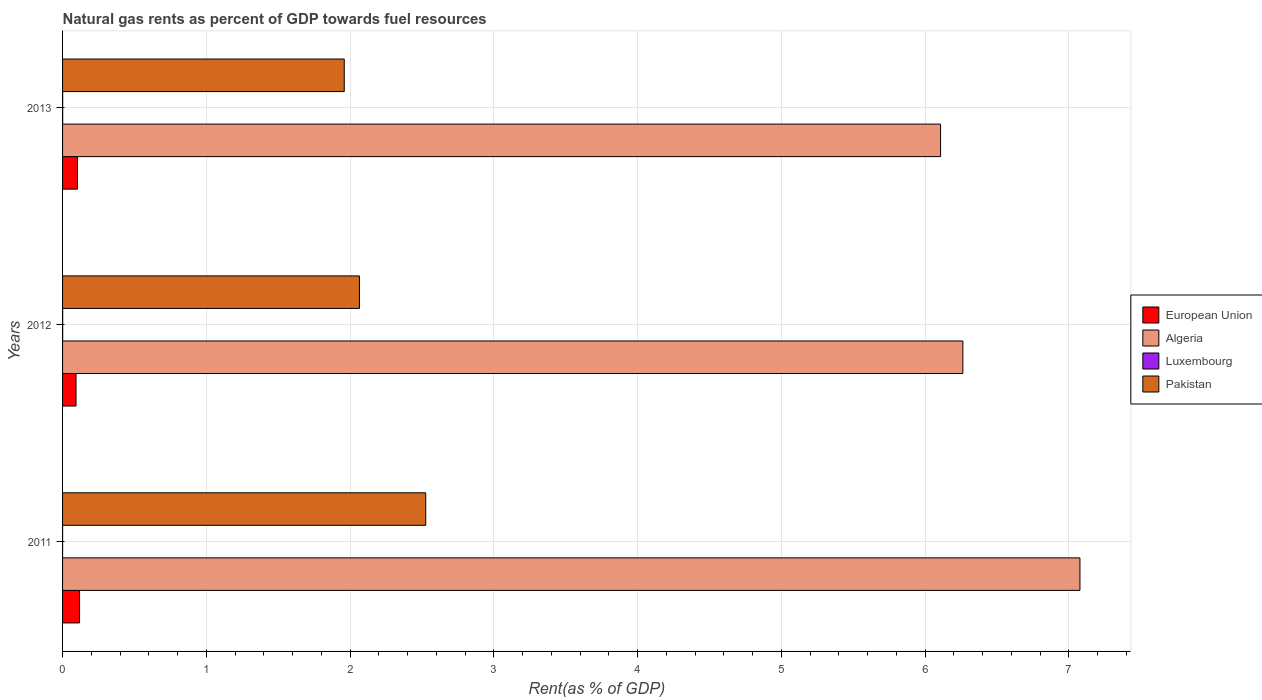How many different coloured bars are there?
Provide a short and direct response. 4. In how many cases, is the number of bars for a given year not equal to the number of legend labels?
Your response must be concise. 0. What is the matural gas rent in Algeria in 2011?
Ensure brevity in your answer.  7.08. Across all years, what is the maximum matural gas rent in Algeria?
Your answer should be very brief. 7.08. Across all years, what is the minimum matural gas rent in European Union?
Offer a terse response. 0.09. In which year was the matural gas rent in Algeria maximum?
Your answer should be compact. 2011. In which year was the matural gas rent in Luxembourg minimum?
Provide a short and direct response. 2011. What is the total matural gas rent in Luxembourg in the graph?
Provide a short and direct response. 0. What is the difference between the matural gas rent in European Union in 2011 and that in 2012?
Offer a terse response. 0.02. What is the difference between the matural gas rent in European Union in 2011 and the matural gas rent in Pakistan in 2012?
Provide a short and direct response. -1.95. What is the average matural gas rent in European Union per year?
Keep it short and to the point. 0.11. In the year 2013, what is the difference between the matural gas rent in European Union and matural gas rent in Pakistan?
Offer a terse response. -1.86. In how many years, is the matural gas rent in Pakistan greater than 6.2 %?
Make the answer very short. 0. What is the ratio of the matural gas rent in Algeria in 2011 to that in 2013?
Offer a terse response. 1.16. Is the matural gas rent in Luxembourg in 2011 less than that in 2012?
Your response must be concise. Yes. Is the difference between the matural gas rent in European Union in 2012 and 2013 greater than the difference between the matural gas rent in Pakistan in 2012 and 2013?
Your response must be concise. No. What is the difference between the highest and the second highest matural gas rent in Pakistan?
Give a very brief answer. 0.46. What is the difference between the highest and the lowest matural gas rent in Luxembourg?
Your answer should be very brief. 0. In how many years, is the matural gas rent in Luxembourg greater than the average matural gas rent in Luxembourg taken over all years?
Offer a very short reply. 2. Is the sum of the matural gas rent in Pakistan in 2012 and 2013 greater than the maximum matural gas rent in Algeria across all years?
Provide a short and direct response. No. Is it the case that in every year, the sum of the matural gas rent in Algeria and matural gas rent in European Union is greater than the sum of matural gas rent in Luxembourg and matural gas rent in Pakistan?
Your answer should be compact. Yes. What does the 2nd bar from the top in 2013 represents?
Your response must be concise. Luxembourg. How many bars are there?
Your answer should be very brief. 12. Does the graph contain any zero values?
Your response must be concise. No. Where does the legend appear in the graph?
Offer a terse response. Center right. How many legend labels are there?
Your answer should be compact. 4. How are the legend labels stacked?
Your answer should be very brief. Vertical. What is the title of the graph?
Provide a short and direct response. Natural gas rents as percent of GDP towards fuel resources. What is the label or title of the X-axis?
Give a very brief answer. Rent(as % of GDP). What is the label or title of the Y-axis?
Your answer should be compact. Years. What is the Rent(as % of GDP) of European Union in 2011?
Keep it short and to the point. 0.12. What is the Rent(as % of GDP) in Algeria in 2011?
Provide a succinct answer. 7.08. What is the Rent(as % of GDP) of Luxembourg in 2011?
Give a very brief answer. 0. What is the Rent(as % of GDP) of Pakistan in 2011?
Keep it short and to the point. 2.53. What is the Rent(as % of GDP) of European Union in 2012?
Your answer should be compact. 0.09. What is the Rent(as % of GDP) in Algeria in 2012?
Give a very brief answer. 6.26. What is the Rent(as % of GDP) of Luxembourg in 2012?
Keep it short and to the point. 0. What is the Rent(as % of GDP) in Pakistan in 2012?
Provide a succinct answer. 2.07. What is the Rent(as % of GDP) of European Union in 2013?
Your response must be concise. 0.1. What is the Rent(as % of GDP) of Algeria in 2013?
Offer a terse response. 6.11. What is the Rent(as % of GDP) of Luxembourg in 2013?
Give a very brief answer. 0. What is the Rent(as % of GDP) in Pakistan in 2013?
Ensure brevity in your answer.  1.96. Across all years, what is the maximum Rent(as % of GDP) of European Union?
Give a very brief answer. 0.12. Across all years, what is the maximum Rent(as % of GDP) of Algeria?
Make the answer very short. 7.08. Across all years, what is the maximum Rent(as % of GDP) in Luxembourg?
Provide a succinct answer. 0. Across all years, what is the maximum Rent(as % of GDP) in Pakistan?
Make the answer very short. 2.53. Across all years, what is the minimum Rent(as % of GDP) of European Union?
Offer a terse response. 0.09. Across all years, what is the minimum Rent(as % of GDP) of Algeria?
Keep it short and to the point. 6.11. Across all years, what is the minimum Rent(as % of GDP) in Luxembourg?
Your answer should be compact. 0. Across all years, what is the minimum Rent(as % of GDP) of Pakistan?
Your answer should be very brief. 1.96. What is the total Rent(as % of GDP) in European Union in the graph?
Your response must be concise. 0.32. What is the total Rent(as % of GDP) of Algeria in the graph?
Provide a succinct answer. 19.45. What is the total Rent(as % of GDP) in Luxembourg in the graph?
Your answer should be very brief. 0. What is the total Rent(as % of GDP) in Pakistan in the graph?
Make the answer very short. 6.55. What is the difference between the Rent(as % of GDP) in European Union in 2011 and that in 2012?
Keep it short and to the point. 0.02. What is the difference between the Rent(as % of GDP) of Algeria in 2011 and that in 2012?
Offer a very short reply. 0.81. What is the difference between the Rent(as % of GDP) of Luxembourg in 2011 and that in 2012?
Offer a very short reply. -0. What is the difference between the Rent(as % of GDP) in Pakistan in 2011 and that in 2012?
Provide a short and direct response. 0.46. What is the difference between the Rent(as % of GDP) in European Union in 2011 and that in 2013?
Make the answer very short. 0.01. What is the difference between the Rent(as % of GDP) in Algeria in 2011 and that in 2013?
Keep it short and to the point. 0.97. What is the difference between the Rent(as % of GDP) of Luxembourg in 2011 and that in 2013?
Your answer should be very brief. -0. What is the difference between the Rent(as % of GDP) of Pakistan in 2011 and that in 2013?
Your answer should be very brief. 0.57. What is the difference between the Rent(as % of GDP) in European Union in 2012 and that in 2013?
Your answer should be very brief. -0.01. What is the difference between the Rent(as % of GDP) in Algeria in 2012 and that in 2013?
Offer a terse response. 0.15. What is the difference between the Rent(as % of GDP) in Pakistan in 2012 and that in 2013?
Offer a very short reply. 0.11. What is the difference between the Rent(as % of GDP) in European Union in 2011 and the Rent(as % of GDP) in Algeria in 2012?
Make the answer very short. -6.14. What is the difference between the Rent(as % of GDP) of European Union in 2011 and the Rent(as % of GDP) of Luxembourg in 2012?
Provide a succinct answer. 0.12. What is the difference between the Rent(as % of GDP) in European Union in 2011 and the Rent(as % of GDP) in Pakistan in 2012?
Provide a succinct answer. -1.95. What is the difference between the Rent(as % of GDP) in Algeria in 2011 and the Rent(as % of GDP) in Luxembourg in 2012?
Ensure brevity in your answer.  7.08. What is the difference between the Rent(as % of GDP) in Algeria in 2011 and the Rent(as % of GDP) in Pakistan in 2012?
Provide a short and direct response. 5.01. What is the difference between the Rent(as % of GDP) of Luxembourg in 2011 and the Rent(as % of GDP) of Pakistan in 2012?
Your answer should be compact. -2.06. What is the difference between the Rent(as % of GDP) in European Union in 2011 and the Rent(as % of GDP) in Algeria in 2013?
Give a very brief answer. -5.99. What is the difference between the Rent(as % of GDP) in European Union in 2011 and the Rent(as % of GDP) in Luxembourg in 2013?
Your answer should be very brief. 0.12. What is the difference between the Rent(as % of GDP) in European Union in 2011 and the Rent(as % of GDP) in Pakistan in 2013?
Offer a terse response. -1.84. What is the difference between the Rent(as % of GDP) of Algeria in 2011 and the Rent(as % of GDP) of Luxembourg in 2013?
Make the answer very short. 7.08. What is the difference between the Rent(as % of GDP) in Algeria in 2011 and the Rent(as % of GDP) in Pakistan in 2013?
Provide a short and direct response. 5.12. What is the difference between the Rent(as % of GDP) of Luxembourg in 2011 and the Rent(as % of GDP) of Pakistan in 2013?
Keep it short and to the point. -1.96. What is the difference between the Rent(as % of GDP) in European Union in 2012 and the Rent(as % of GDP) in Algeria in 2013?
Give a very brief answer. -6.01. What is the difference between the Rent(as % of GDP) in European Union in 2012 and the Rent(as % of GDP) in Luxembourg in 2013?
Your answer should be very brief. 0.09. What is the difference between the Rent(as % of GDP) of European Union in 2012 and the Rent(as % of GDP) of Pakistan in 2013?
Your answer should be very brief. -1.87. What is the difference between the Rent(as % of GDP) in Algeria in 2012 and the Rent(as % of GDP) in Luxembourg in 2013?
Provide a short and direct response. 6.26. What is the difference between the Rent(as % of GDP) of Algeria in 2012 and the Rent(as % of GDP) of Pakistan in 2013?
Provide a short and direct response. 4.3. What is the difference between the Rent(as % of GDP) of Luxembourg in 2012 and the Rent(as % of GDP) of Pakistan in 2013?
Give a very brief answer. -1.96. What is the average Rent(as % of GDP) of European Union per year?
Make the answer very short. 0.11. What is the average Rent(as % of GDP) in Algeria per year?
Keep it short and to the point. 6.48. What is the average Rent(as % of GDP) of Pakistan per year?
Give a very brief answer. 2.18. In the year 2011, what is the difference between the Rent(as % of GDP) of European Union and Rent(as % of GDP) of Algeria?
Your response must be concise. -6.96. In the year 2011, what is the difference between the Rent(as % of GDP) in European Union and Rent(as % of GDP) in Luxembourg?
Make the answer very short. 0.12. In the year 2011, what is the difference between the Rent(as % of GDP) of European Union and Rent(as % of GDP) of Pakistan?
Offer a very short reply. -2.41. In the year 2011, what is the difference between the Rent(as % of GDP) in Algeria and Rent(as % of GDP) in Luxembourg?
Provide a succinct answer. 7.08. In the year 2011, what is the difference between the Rent(as % of GDP) in Algeria and Rent(as % of GDP) in Pakistan?
Offer a terse response. 4.55. In the year 2011, what is the difference between the Rent(as % of GDP) of Luxembourg and Rent(as % of GDP) of Pakistan?
Your answer should be compact. -2.53. In the year 2012, what is the difference between the Rent(as % of GDP) of European Union and Rent(as % of GDP) of Algeria?
Keep it short and to the point. -6.17. In the year 2012, what is the difference between the Rent(as % of GDP) in European Union and Rent(as % of GDP) in Luxembourg?
Provide a succinct answer. 0.09. In the year 2012, what is the difference between the Rent(as % of GDP) of European Union and Rent(as % of GDP) of Pakistan?
Make the answer very short. -1.97. In the year 2012, what is the difference between the Rent(as % of GDP) of Algeria and Rent(as % of GDP) of Luxembourg?
Offer a terse response. 6.26. In the year 2012, what is the difference between the Rent(as % of GDP) in Algeria and Rent(as % of GDP) in Pakistan?
Give a very brief answer. 4.2. In the year 2012, what is the difference between the Rent(as % of GDP) in Luxembourg and Rent(as % of GDP) in Pakistan?
Keep it short and to the point. -2.06. In the year 2013, what is the difference between the Rent(as % of GDP) of European Union and Rent(as % of GDP) of Algeria?
Offer a terse response. -6. In the year 2013, what is the difference between the Rent(as % of GDP) in European Union and Rent(as % of GDP) in Luxembourg?
Offer a very short reply. 0.1. In the year 2013, what is the difference between the Rent(as % of GDP) of European Union and Rent(as % of GDP) of Pakistan?
Make the answer very short. -1.86. In the year 2013, what is the difference between the Rent(as % of GDP) of Algeria and Rent(as % of GDP) of Luxembourg?
Give a very brief answer. 6.11. In the year 2013, what is the difference between the Rent(as % of GDP) in Algeria and Rent(as % of GDP) in Pakistan?
Give a very brief answer. 4.15. In the year 2013, what is the difference between the Rent(as % of GDP) of Luxembourg and Rent(as % of GDP) of Pakistan?
Offer a very short reply. -1.96. What is the ratio of the Rent(as % of GDP) of European Union in 2011 to that in 2012?
Keep it short and to the point. 1.26. What is the ratio of the Rent(as % of GDP) in Algeria in 2011 to that in 2012?
Give a very brief answer. 1.13. What is the ratio of the Rent(as % of GDP) of Luxembourg in 2011 to that in 2012?
Keep it short and to the point. 0.3. What is the ratio of the Rent(as % of GDP) in Pakistan in 2011 to that in 2012?
Provide a succinct answer. 1.22. What is the ratio of the Rent(as % of GDP) in European Union in 2011 to that in 2013?
Your answer should be compact. 1.14. What is the ratio of the Rent(as % of GDP) of Algeria in 2011 to that in 2013?
Keep it short and to the point. 1.16. What is the ratio of the Rent(as % of GDP) in Luxembourg in 2011 to that in 2013?
Provide a short and direct response. 0.31. What is the ratio of the Rent(as % of GDP) of Pakistan in 2011 to that in 2013?
Make the answer very short. 1.29. What is the ratio of the Rent(as % of GDP) of European Union in 2012 to that in 2013?
Provide a succinct answer. 0.9. What is the ratio of the Rent(as % of GDP) in Algeria in 2012 to that in 2013?
Keep it short and to the point. 1.03. What is the ratio of the Rent(as % of GDP) in Luxembourg in 2012 to that in 2013?
Your answer should be compact. 1.03. What is the ratio of the Rent(as % of GDP) in Pakistan in 2012 to that in 2013?
Make the answer very short. 1.05. What is the difference between the highest and the second highest Rent(as % of GDP) in European Union?
Provide a succinct answer. 0.01. What is the difference between the highest and the second highest Rent(as % of GDP) of Algeria?
Keep it short and to the point. 0.81. What is the difference between the highest and the second highest Rent(as % of GDP) in Luxembourg?
Offer a very short reply. 0. What is the difference between the highest and the second highest Rent(as % of GDP) of Pakistan?
Provide a succinct answer. 0.46. What is the difference between the highest and the lowest Rent(as % of GDP) in European Union?
Your response must be concise. 0.02. What is the difference between the highest and the lowest Rent(as % of GDP) in Algeria?
Your response must be concise. 0.97. What is the difference between the highest and the lowest Rent(as % of GDP) of Luxembourg?
Make the answer very short. 0. What is the difference between the highest and the lowest Rent(as % of GDP) of Pakistan?
Ensure brevity in your answer.  0.57. 